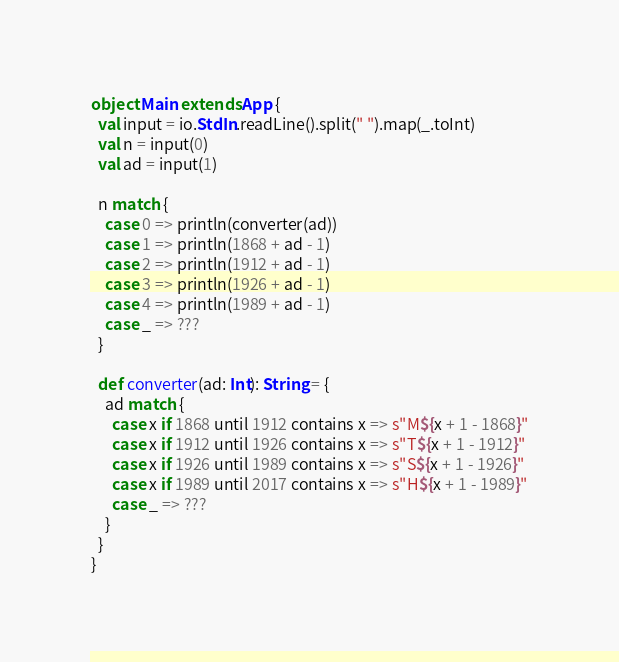Convert code to text. <code><loc_0><loc_0><loc_500><loc_500><_Scala_>object Main extends App {
  val input = io.StdIn.readLine().split(" ").map(_.toInt)
  val n = input(0)
  val ad = input(1)

  n match {
    case 0 => println(converter(ad))
    case 1 => println(1868 + ad - 1)
    case 2 => println(1912 + ad - 1)
    case 3 => println(1926 + ad - 1)
    case 4 => println(1989 + ad - 1)
    case _ => ???
  }

  def converter(ad: Int): String = {
    ad match {
      case x if 1868 until 1912 contains x => s"M${x + 1 - 1868}"
      case x if 1912 until 1926 contains x => s"T${x + 1 - 1912}"
      case x if 1926 until 1989 contains x => s"S${x + 1 - 1926}"
      case x if 1989 until 2017 contains x => s"H${x + 1 - 1989}"
      case _ => ???
    }
  }
}
</code> 